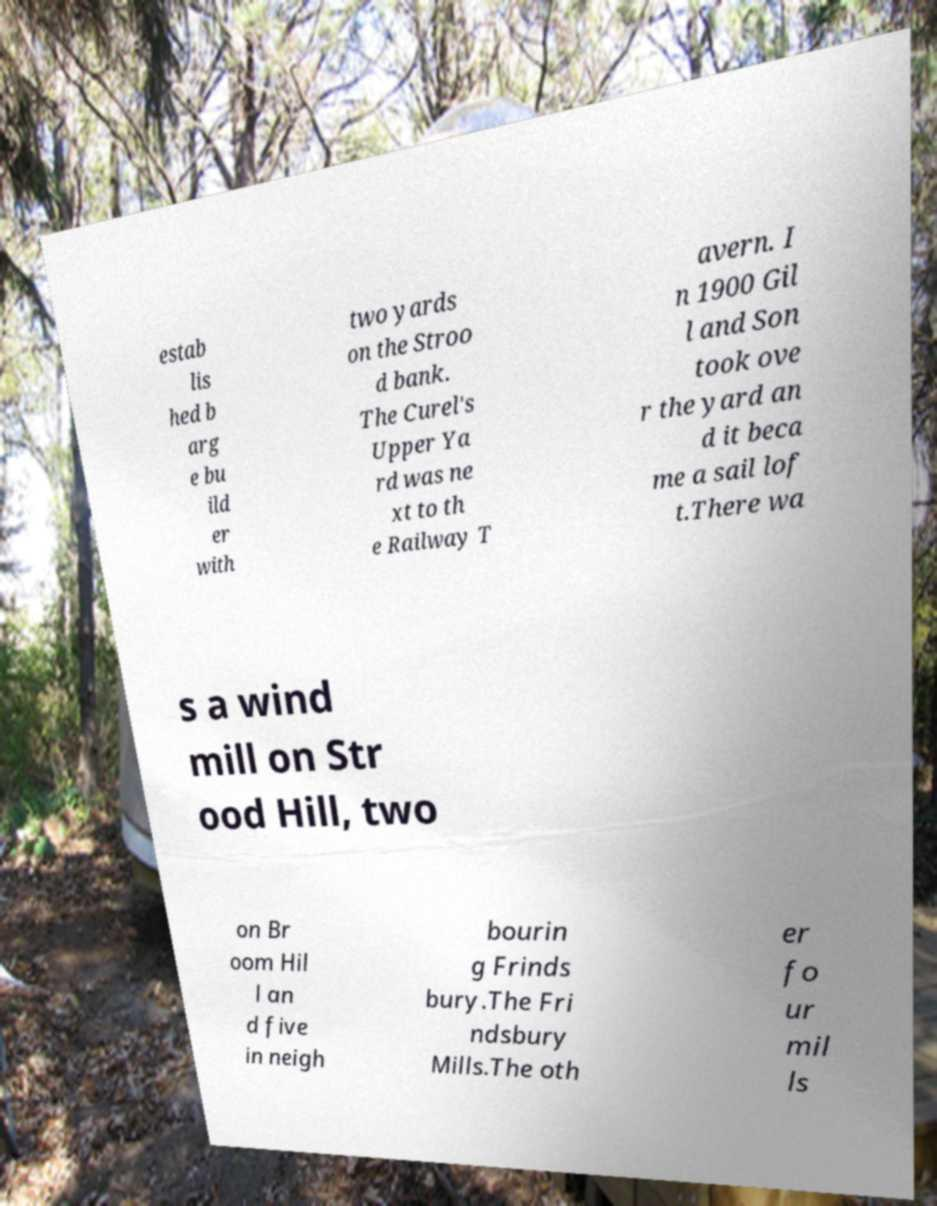There's text embedded in this image that I need extracted. Can you transcribe it verbatim? estab lis hed b arg e bu ild er with two yards on the Stroo d bank. The Curel's Upper Ya rd was ne xt to th e Railway T avern. I n 1900 Gil l and Son took ove r the yard an d it beca me a sail lof t.There wa s a wind mill on Str ood Hill, two on Br oom Hil l an d five in neigh bourin g Frinds bury.The Fri ndsbury Mills.The oth er fo ur mil ls 